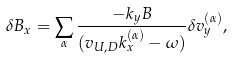<formula> <loc_0><loc_0><loc_500><loc_500>\delta B _ { x } = \sum _ { \alpha } \frac { - k _ { y } B } { ( v _ { U , D } k _ { x } ^ { ( \alpha ) } - \omega ) } \delta v _ { y } ^ { ( \alpha ) } ,</formula> 